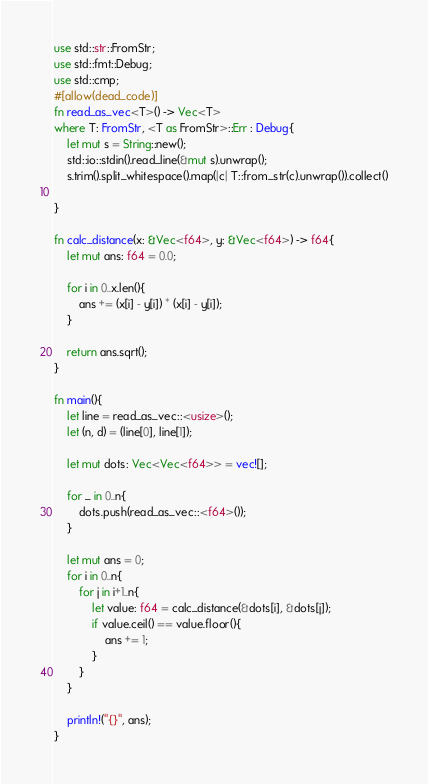Convert code to text. <code><loc_0><loc_0><loc_500><loc_500><_Rust_>use std::str::FromStr;
use std::fmt::Debug;
use std::cmp;
#[allow(dead_code)]
fn read_as_vec<T>() -> Vec<T>
where T: FromStr, <T as FromStr>::Err : Debug{
    let mut s = String::new();
    std::io::stdin().read_line(&mut s).unwrap();
    s.trim().split_whitespace().map(|c| T::from_str(c).unwrap()).collect()

}

fn calc_distance(x: &Vec<f64>, y: &Vec<f64>) -> f64{
    let mut ans: f64 = 0.0;

    for i in 0..x.len(){
        ans += (x[i] - y[i]) * (x[i] - y[i]);
    }

    return ans.sqrt();
}

fn main(){
    let line = read_as_vec::<usize>();
    let (n, d) = (line[0], line[1]);

    let mut dots: Vec<Vec<f64>> = vec![];

    for _ in 0..n{
        dots.push(read_as_vec::<f64>());
    }

    let mut ans = 0;
    for i in 0..n{
        for j in i+1..n{
            let value: f64 = calc_distance(&dots[i], &dots[j]);
            if value.ceil() == value.floor(){
                ans += 1;
            }
        }
    }

    println!("{}", ans);
}
</code> 